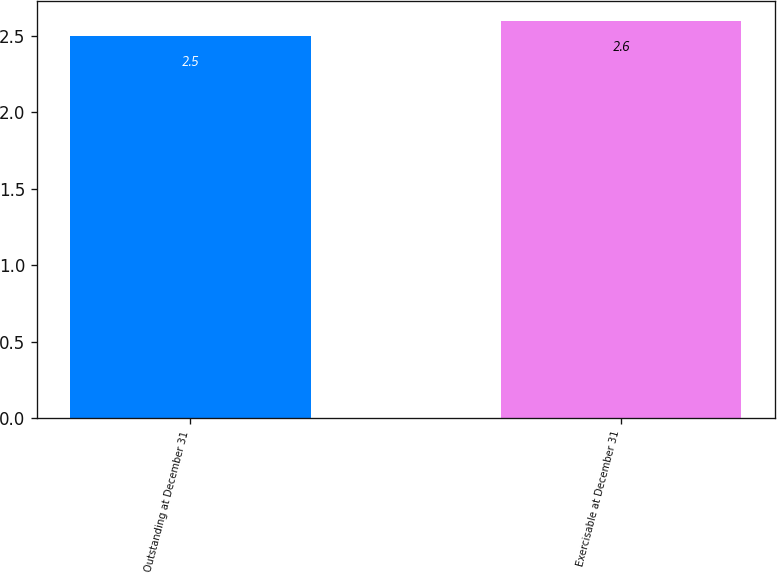Convert chart to OTSL. <chart><loc_0><loc_0><loc_500><loc_500><bar_chart><fcel>Outstanding at December 31<fcel>Exercisable at December 31<nl><fcel>2.5<fcel>2.6<nl></chart> 